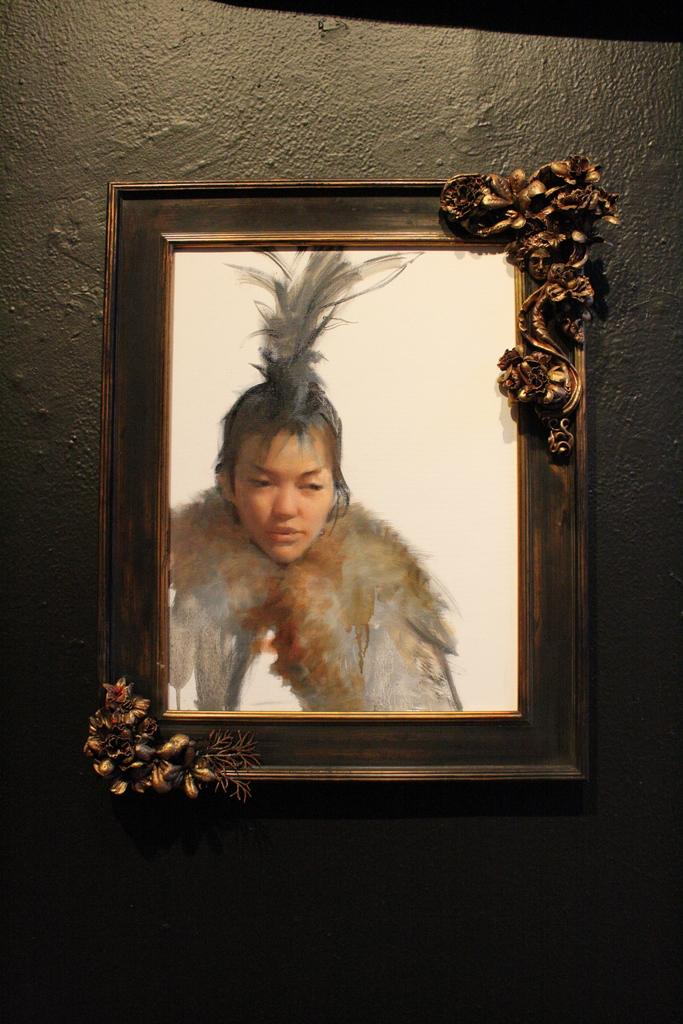What is hanging on the wall in the image? There is a photo frame on the wall in the image. What is inside the photo frame? The photo frame contains a photo. Who or what is depicted in the photo? The photo depicts a girl. How many eggs are visible in the photo frame? There are no eggs visible in the photo frame; it contains a photo of a girl. 